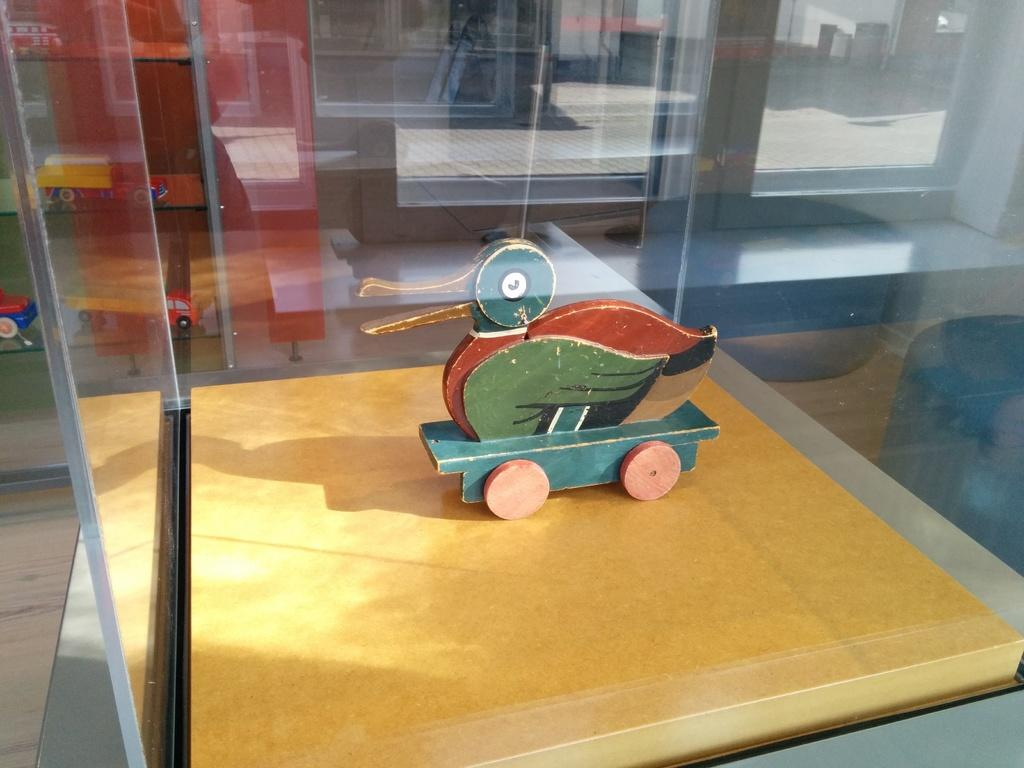What is the main subject in the center of the image? There is a toy in the center of the image. What type of enclosure surrounds the toy? There are glass walls surrounding the toy. Where can other toys be found in the image? There are other toys on shelves on the left side of the image. What type of property does the governor own in the image? There is no mention of a governor or property in the image; it features a toy surrounded by glass walls and other toys on shelves. 